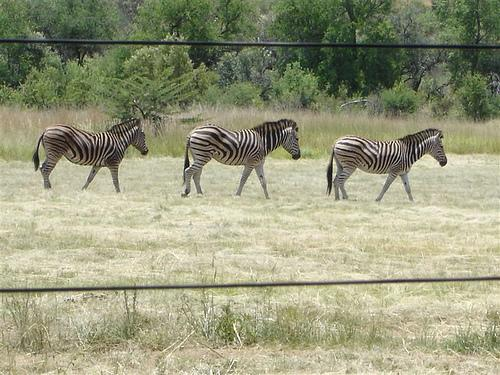How many zebra are walking in a line behind the fence? Please explain your reasoning. three. There are three zebras behind the fence. 